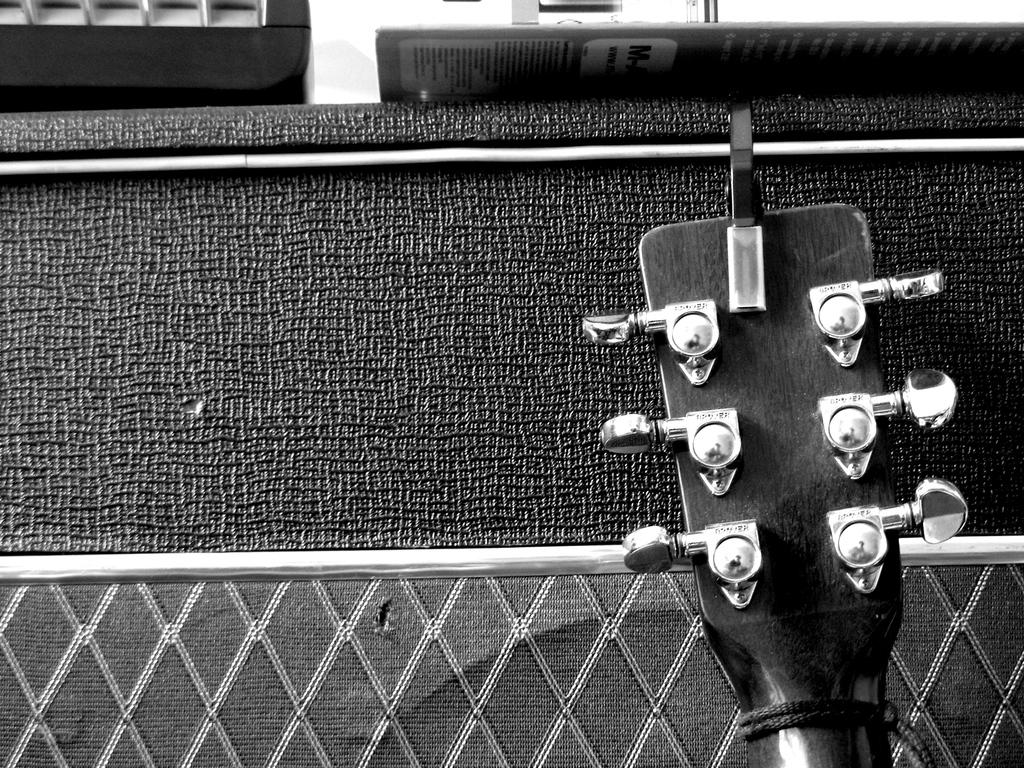What is the color scheme of the picture? The picture is black and white. What object can be seen in the picture? There is a guitar head in the picture. What type of cracker is being used to play the guitar in the picture? There is no cracker present in the picture, and the guitar is not being played. 